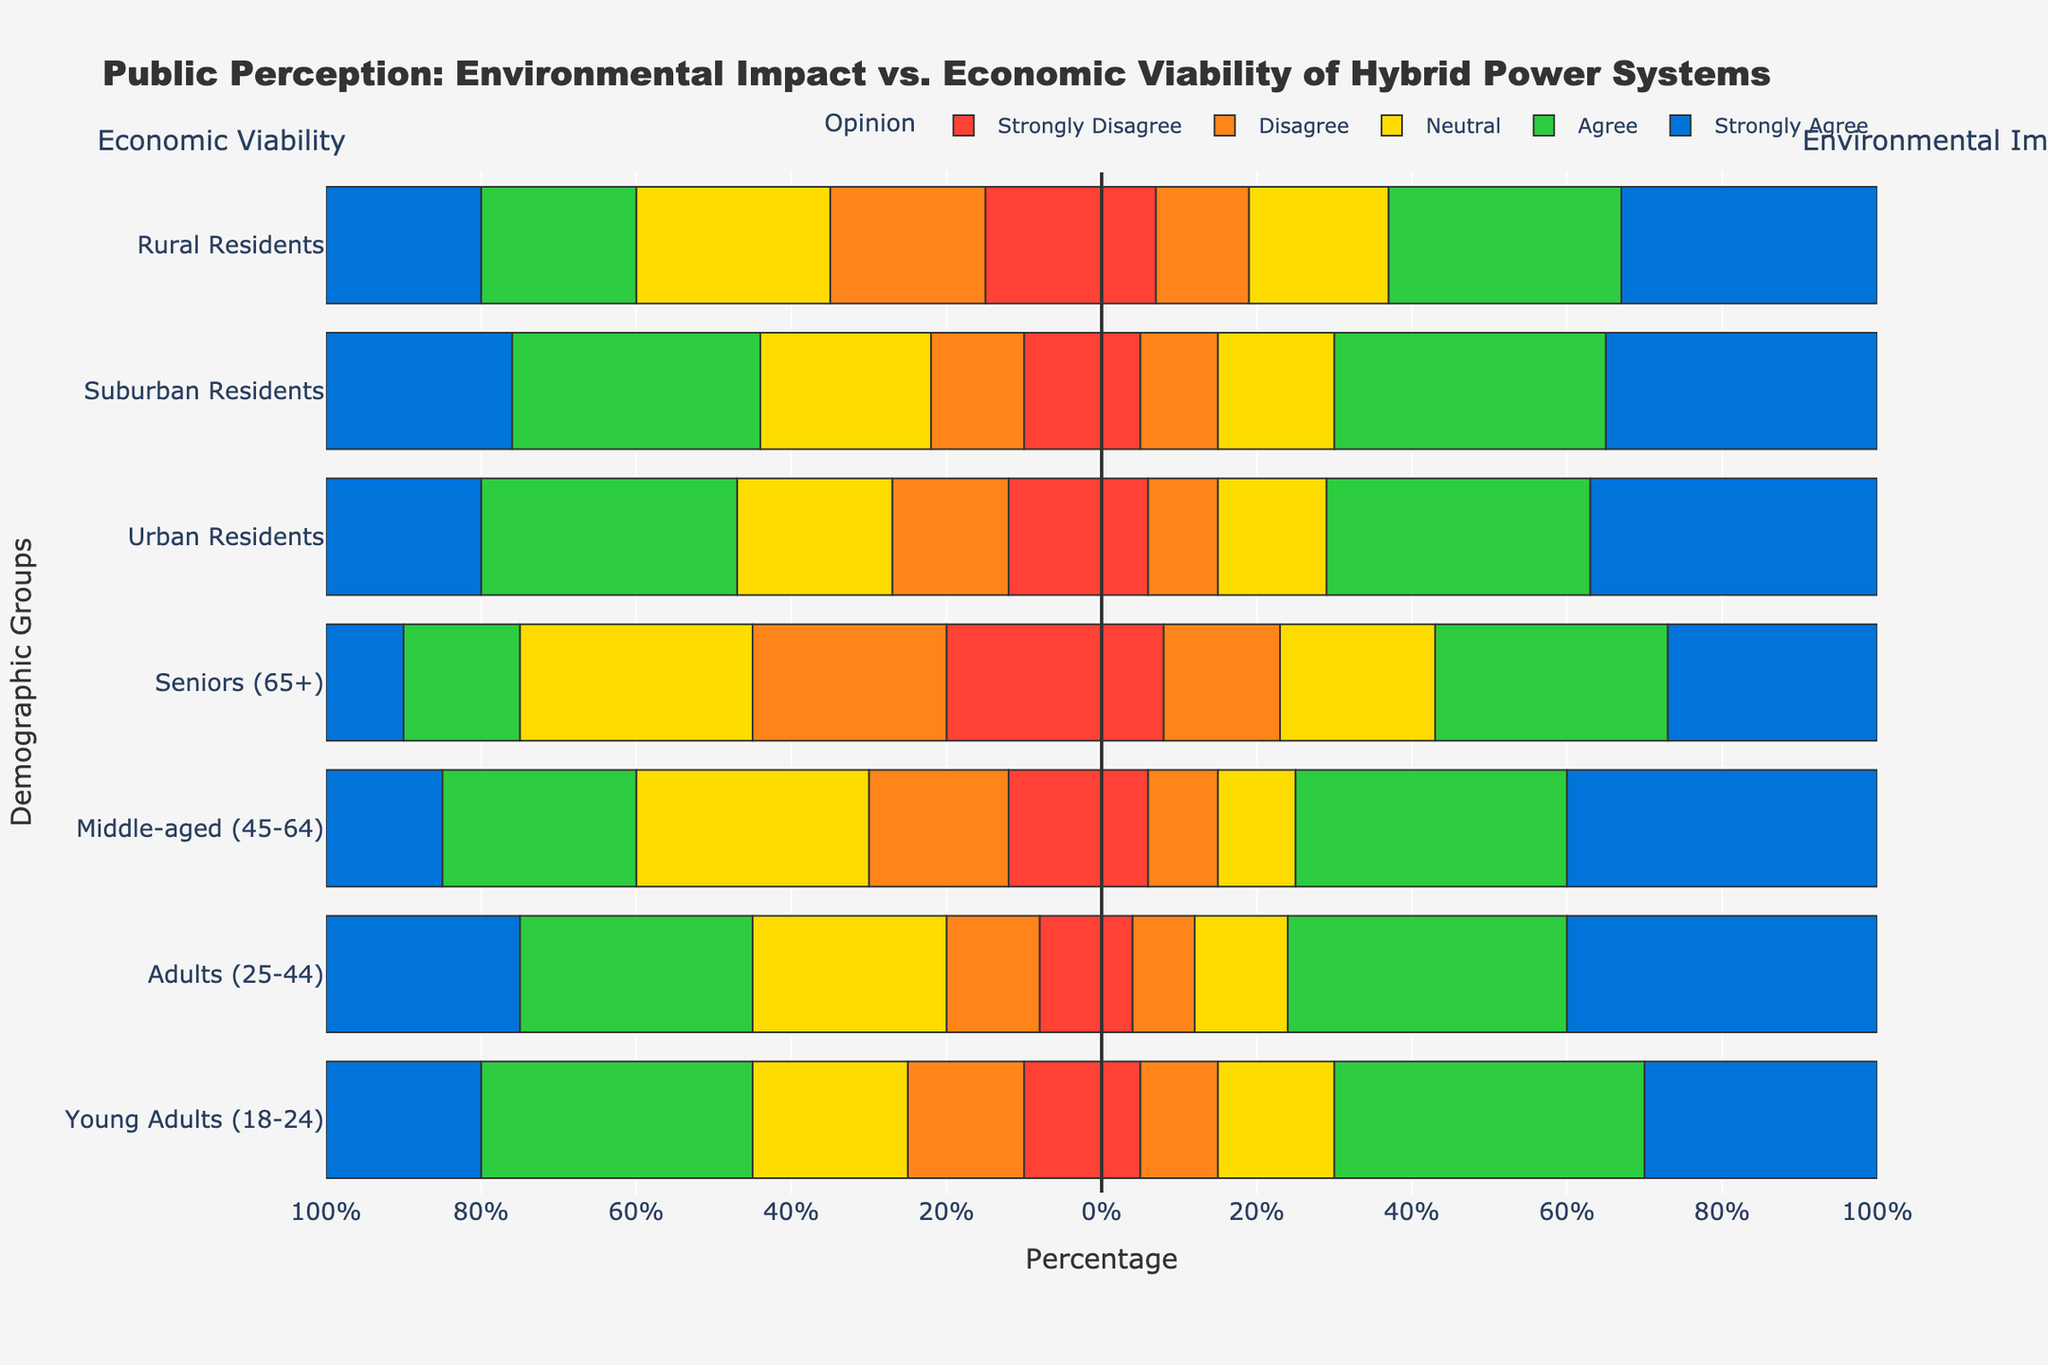Which demographic group shows the highest agreement with the economic viability of hybrid power systems? For economic viability, the "Agree" and "Strongly Agree" values should be noted. The group "Adults (25-44)" has a combined total of 55% (30% Agree + 25% Strongly Agree), which is the highest.
Answer: Adults (25-44) Which demographic group shows the highest disagreement with the environmental impact improvements of hybrid power systems? For environmental impact improvements, the "Strongly Disagree" and "Disagree" values need to be checked. The group "Seniors (65+)" shows the highest disagreement with a total of 23% (8% Strongly Disagree + 15% Disagree).
Answer: Seniors (65+) What is the total percentage of Middle-aged individuals who have a negative perception (Strongly Disagree + Disagree) about the economic viability of hybrid power systems? The values are 12% (Strongly Disagree) + 18% (Disagree), so the total is 30%.
Answer: 30% Compare the perception of environmental impact improvements between Urban Residents and Suburban Residents. Which group has a higher percentage of positive responses (Agree + Strongly Agree)? Urban Residents: 34% (Agree) + 37% (Strongly Agree) = 71%. Suburban Residents: 35% (Agree) + 35% (Strongly Agree) = 70%. Urban Residents have a slightly higher positive response.
Answer: Urban Residents Considering Young Adults (18-24), calculate the difference in the neutral responses between environmental impact improvements and economic viability. The neutral responses are: Environmental Impact Improvements: 15%, Economic Viability: 20%. The difference is 20% - 15% = 5%.
Answer: 5% Among Rural Residents, do more people agree or disagree with the economic viability of hybrid power systems? For Rural Residents, the "Agree" and "Disagree" responses are 20% and 25%, respectively. Therefore, more people disagree.
Answer: Disagree What percentage of Adults (25-44) have a positive attitude (Agree + Strongly Agree) towards the environmental impact improvements of hybrid power systems? For Adults (25-44): 36% (Agree) + 40% (Strongly Agree) = 76%.
Answer: 76% Which demographic group has the most substantial proportion of neutral responses for economic viability? The group "Middle-aged (45-64)" has the highest neutral responses at 30%.
Answer: Middle-aged (45-64) Is there any demographic group where the disagreement (Strongly Disagree + Disagree) with economic viability is higher than agreement (Agree + Strongly Agree)? Seniors (65+) show higher disagreement (20% Strongly Disagree + 25% Disagree = 45%) compared to agreement (15% Agree + 10% Strongly Agree = 25%).
Answer: Seniors (65+) 